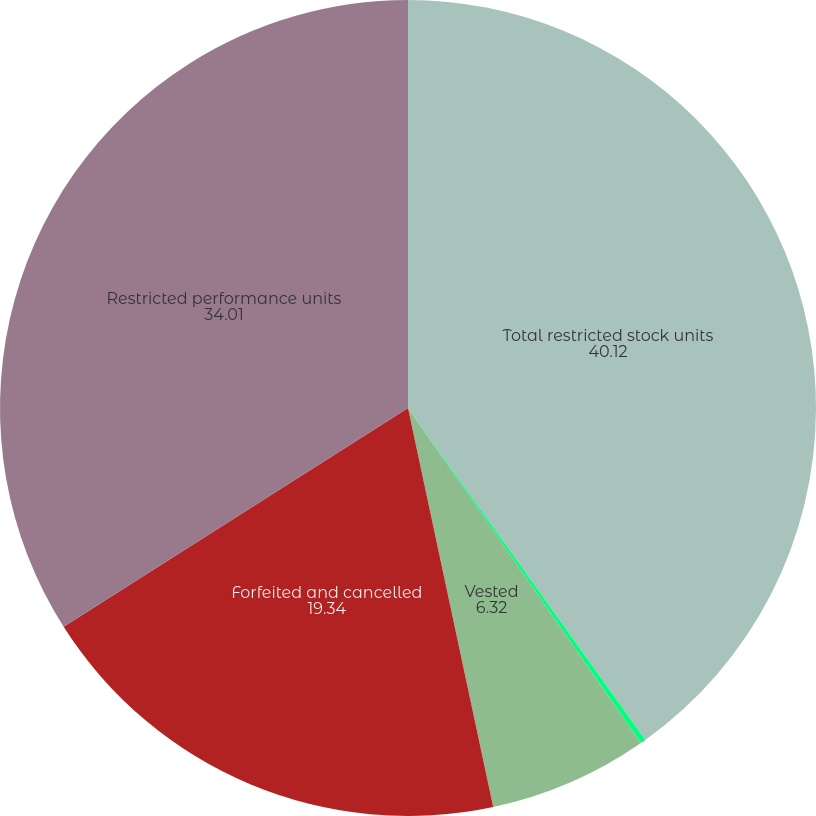Convert chart. <chart><loc_0><loc_0><loc_500><loc_500><pie_chart><fcel>Total restricted stock units<fcel>Granted<fcel>Vested<fcel>Forfeited and cancelled<fcel>Restricted performance units<nl><fcel>40.12%<fcel>0.21%<fcel>6.32%<fcel>19.34%<fcel>34.01%<nl></chart> 